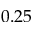<formula> <loc_0><loc_0><loc_500><loc_500>0 . 2 5</formula> 